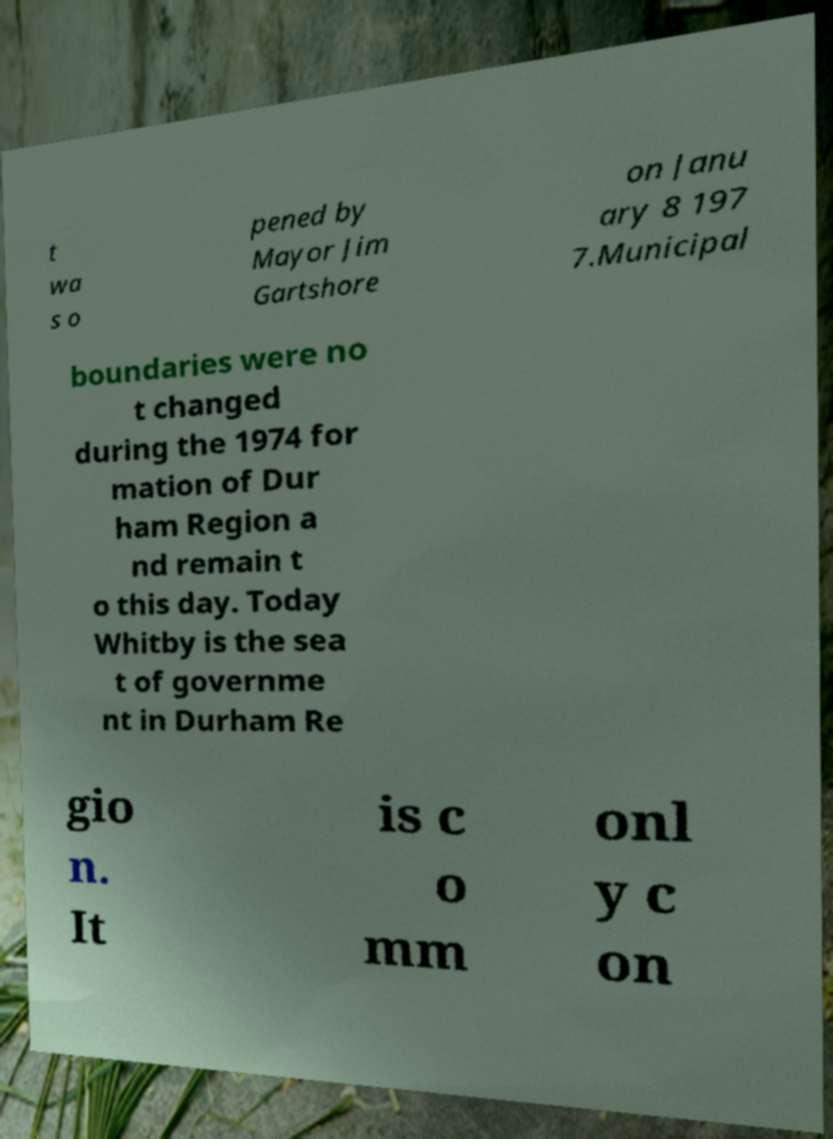Can you read and provide the text displayed in the image?This photo seems to have some interesting text. Can you extract and type it out for me? t wa s o pened by Mayor Jim Gartshore on Janu ary 8 197 7.Municipal boundaries were no t changed during the 1974 for mation of Dur ham Region a nd remain t o this day. Today Whitby is the sea t of governme nt in Durham Re gio n. It is c o mm onl y c on 